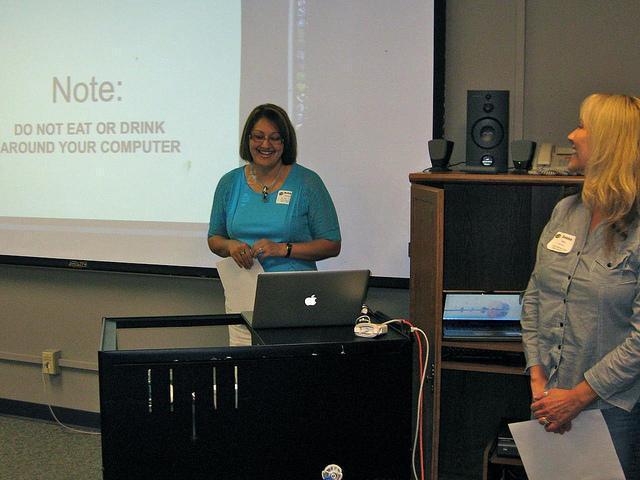How many people in this image are wearing glasses?
Give a very brief answer. 1. How many computers are shown?
Give a very brief answer. 2. How many people are in the photo?
Give a very brief answer. 2. How many laptops are visible?
Give a very brief answer. 2. 